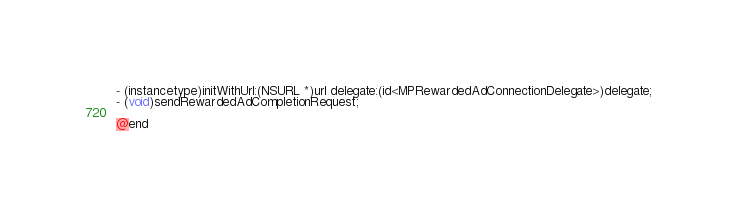Convert code to text. <code><loc_0><loc_0><loc_500><loc_500><_C_>
- (instancetype)initWithUrl:(NSURL *)url delegate:(id<MPRewardedAdConnectionDelegate>)delegate;
- (void)sendRewardedAdCompletionRequest;

@end
</code> 